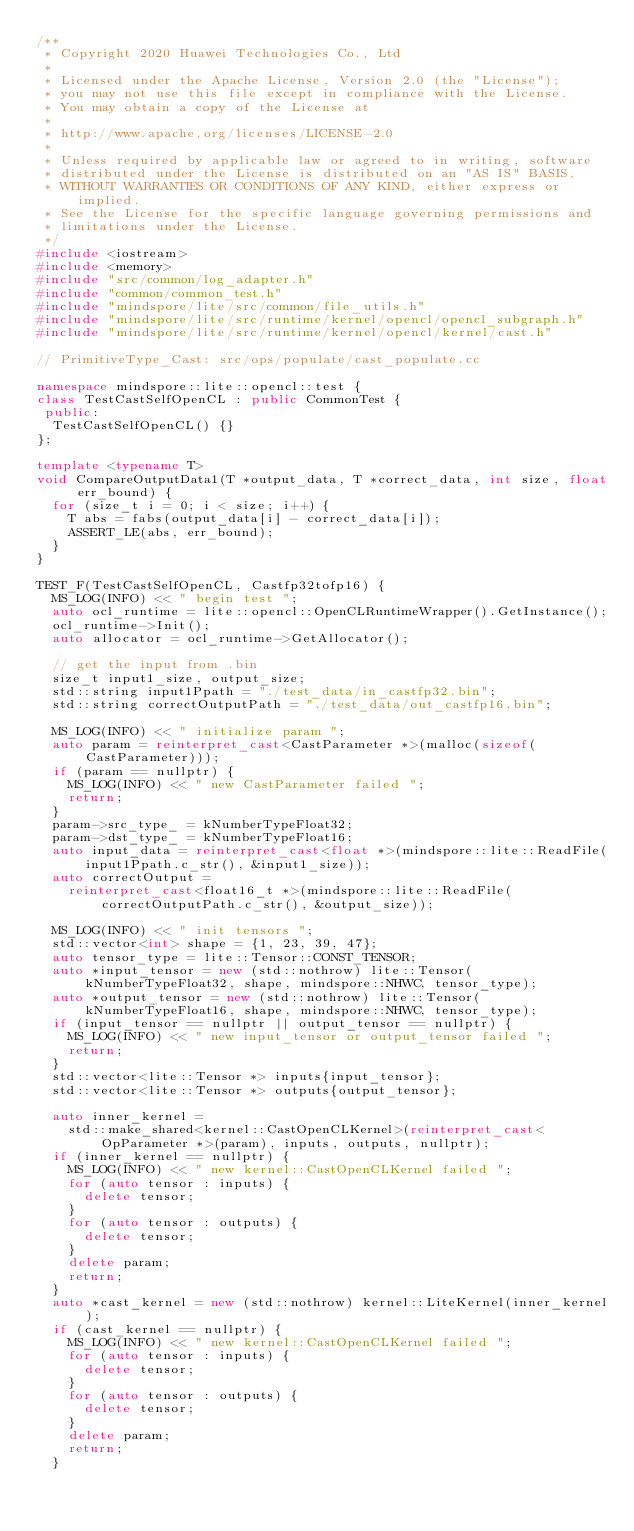<code> <loc_0><loc_0><loc_500><loc_500><_C++_>/**
 * Copyright 2020 Huawei Technologies Co., Ltd
 *
 * Licensed under the Apache License, Version 2.0 (the "License");
 * you may not use this file except in compliance with the License.
 * You may obtain a copy of the License at
 *
 * http://www.apache.org/licenses/LICENSE-2.0
 *
 * Unless required by applicable law or agreed to in writing, software
 * distributed under the License is distributed on an "AS IS" BASIS,
 * WITHOUT WARRANTIES OR CONDITIONS OF ANY KIND, either express or implied.
 * See the License for the specific language governing permissions and
 * limitations under the License.
 */
#include <iostream>
#include <memory>
#include "src/common/log_adapter.h"
#include "common/common_test.h"
#include "mindspore/lite/src/common/file_utils.h"
#include "mindspore/lite/src/runtime/kernel/opencl/opencl_subgraph.h"
#include "mindspore/lite/src/runtime/kernel/opencl/kernel/cast.h"

// PrimitiveType_Cast: src/ops/populate/cast_populate.cc

namespace mindspore::lite::opencl::test {
class TestCastSelfOpenCL : public CommonTest {
 public:
  TestCastSelfOpenCL() {}
};

template <typename T>
void CompareOutputData1(T *output_data, T *correct_data, int size, float err_bound) {
  for (size_t i = 0; i < size; i++) {
    T abs = fabs(output_data[i] - correct_data[i]);
    ASSERT_LE(abs, err_bound);
  }
}

TEST_F(TestCastSelfOpenCL, Castfp32tofp16) {
  MS_LOG(INFO) << " begin test ";
  auto ocl_runtime = lite::opencl::OpenCLRuntimeWrapper().GetInstance();
  ocl_runtime->Init();
  auto allocator = ocl_runtime->GetAllocator();

  // get the input from .bin
  size_t input1_size, output_size;
  std::string input1Ppath = "./test_data/in_castfp32.bin";
  std::string correctOutputPath = "./test_data/out_castfp16.bin";

  MS_LOG(INFO) << " initialize param ";
  auto param = reinterpret_cast<CastParameter *>(malloc(sizeof(CastParameter)));
  if (param == nullptr) {
    MS_LOG(INFO) << " new CastParameter failed ";
    return;
  }
  param->src_type_ = kNumberTypeFloat32;
  param->dst_type_ = kNumberTypeFloat16;
  auto input_data = reinterpret_cast<float *>(mindspore::lite::ReadFile(input1Ppath.c_str(), &input1_size));
  auto correctOutput =
    reinterpret_cast<float16_t *>(mindspore::lite::ReadFile(correctOutputPath.c_str(), &output_size));

  MS_LOG(INFO) << " init tensors ";
  std::vector<int> shape = {1, 23, 39, 47};
  auto tensor_type = lite::Tensor::CONST_TENSOR;
  auto *input_tensor = new (std::nothrow) lite::Tensor(kNumberTypeFloat32, shape, mindspore::NHWC, tensor_type);
  auto *output_tensor = new (std::nothrow) lite::Tensor(kNumberTypeFloat16, shape, mindspore::NHWC, tensor_type);
  if (input_tensor == nullptr || output_tensor == nullptr) {
    MS_LOG(INFO) << " new input_tensor or output_tensor failed ";
    return;
  }
  std::vector<lite::Tensor *> inputs{input_tensor};
  std::vector<lite::Tensor *> outputs{output_tensor};

  auto inner_kernel =
    std::make_shared<kernel::CastOpenCLKernel>(reinterpret_cast<OpParameter *>(param), inputs, outputs, nullptr);
  if (inner_kernel == nullptr) {
    MS_LOG(INFO) << " new kernel::CastOpenCLKernel failed ";
    for (auto tensor : inputs) {
      delete tensor;
    }
    for (auto tensor : outputs) {
      delete tensor;
    }
    delete param;
    return;
  }
  auto *cast_kernel = new (std::nothrow) kernel::LiteKernel(inner_kernel);
  if (cast_kernel == nullptr) {
    MS_LOG(INFO) << " new kernel::CastOpenCLKernel failed ";
    for (auto tensor : inputs) {
      delete tensor;
    }
    for (auto tensor : outputs) {
      delete tensor;
    }
    delete param;
    return;
  }</code> 